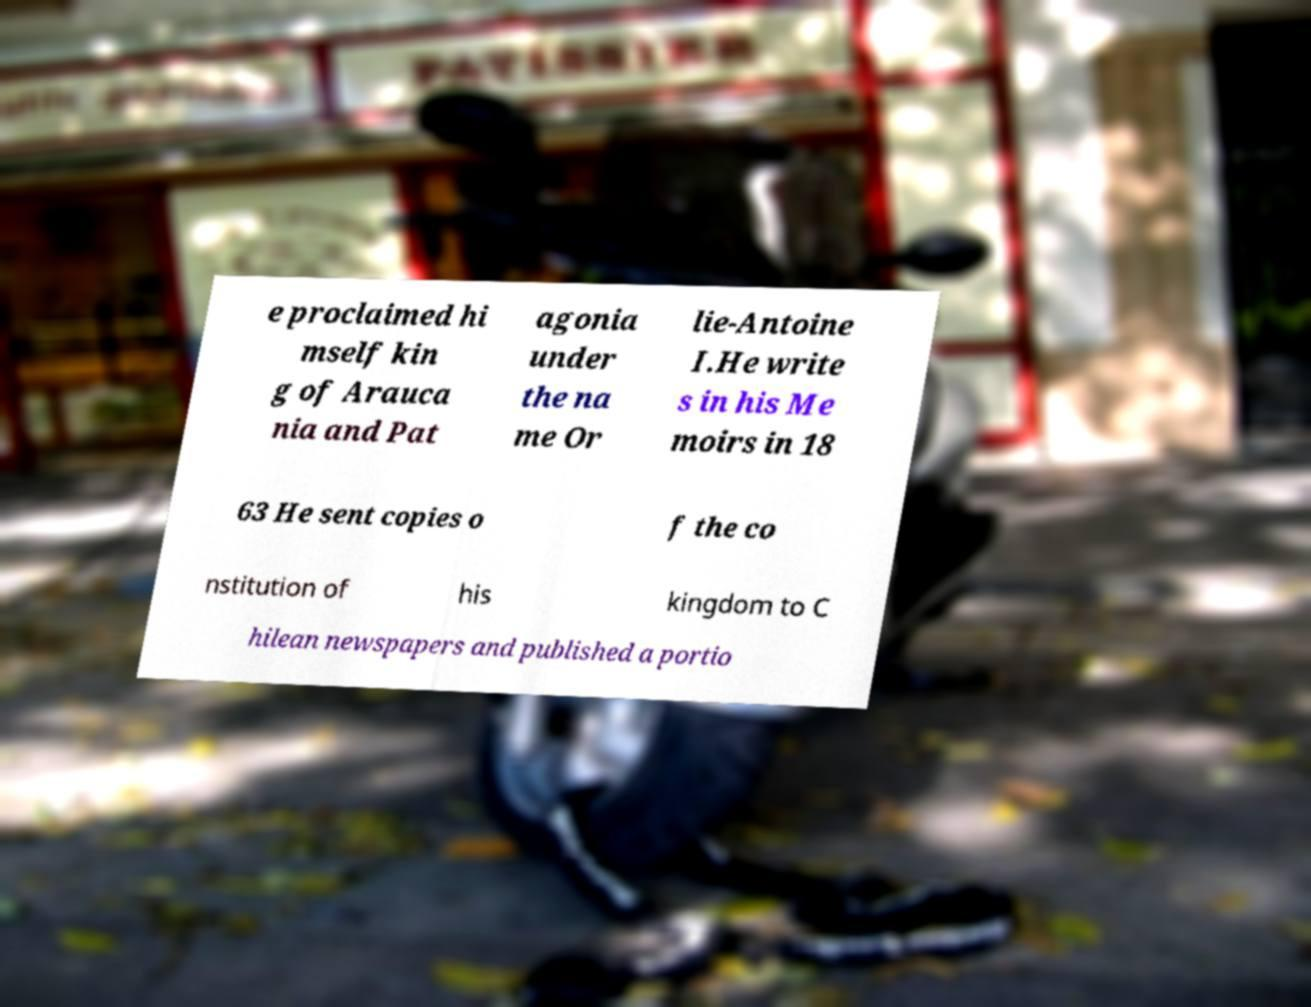Could you assist in decoding the text presented in this image and type it out clearly? e proclaimed hi mself kin g of Arauca nia and Pat agonia under the na me Or lie-Antoine I.He write s in his Me moirs in 18 63 He sent copies o f the co nstitution of his kingdom to C hilean newspapers and published a portio 